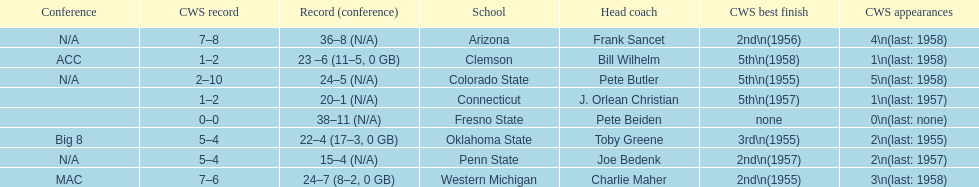Which team did not have more than 16 wins? Penn State. 